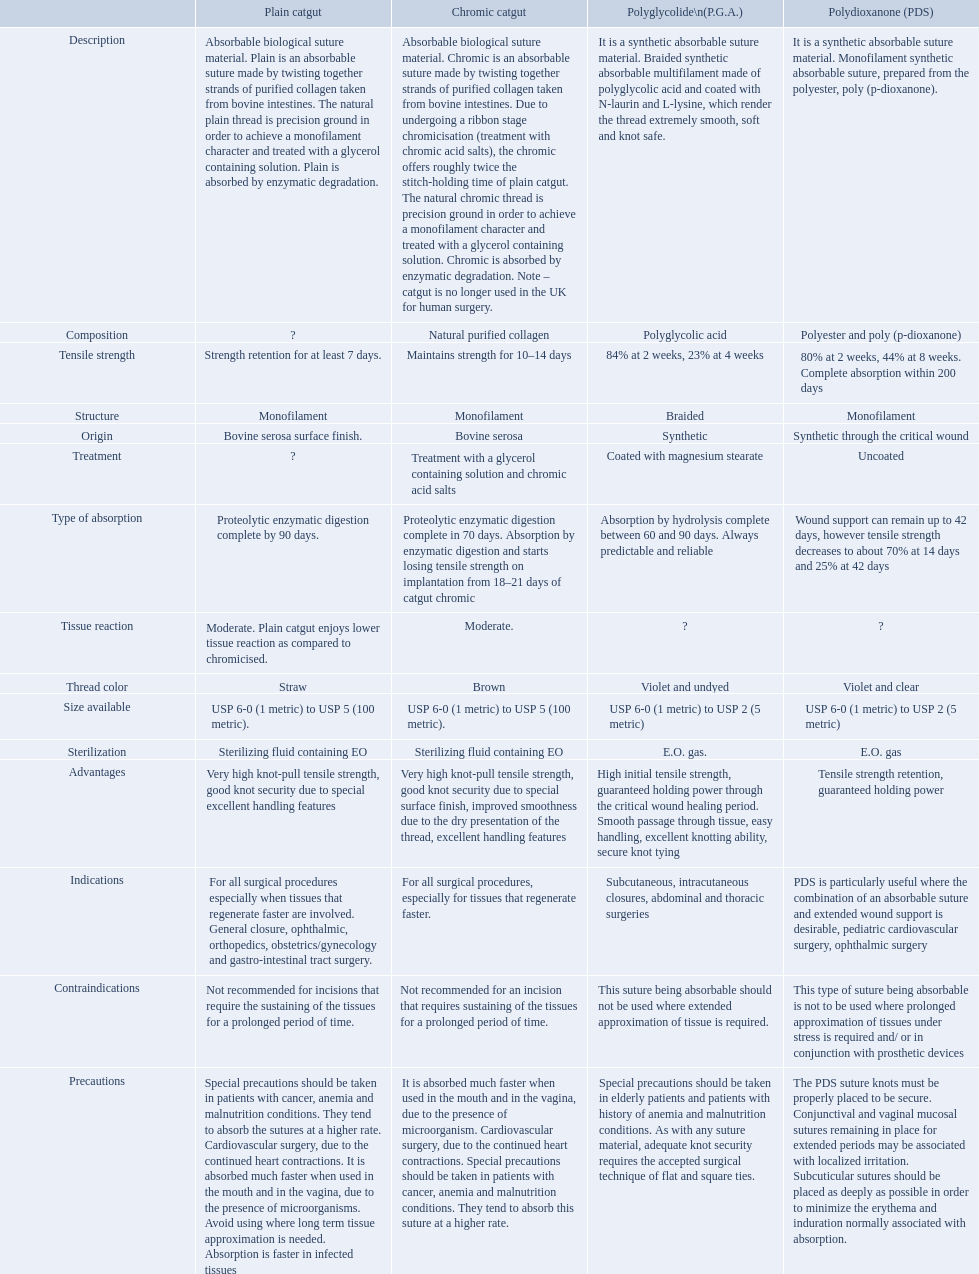How many days does the chronic catgut retain strength? Maintains strength for 10–14 days. What is plain catgut? Absorbable biological suture material. Plain is an absorbable suture made by twisting together strands of purified collagen taken from bovine intestines. The natural plain thread is precision ground in order to achieve a monofilament character and treated with a glycerol containing solution. Plain is absorbed by enzymatic degradation. How many days does catgut retain strength? Strength retention for at least 7 days. What categories are listed in the suture materials comparison chart? Description, Composition, Tensile strength, Structure, Origin, Treatment, Type of absorption, Tissue reaction, Thread color, Size available, Sterilization, Advantages, Indications, Contraindications, Precautions. Of the testile strength, which is the lowest? Strength retention for at least 7 days. Over how many days does chronic catgut keep its robustness? Maintains strength for 10–14 days. What is uncomplicated catgut? Absorbable biological suture material. Plain is an absorbable suture made by twisting together strands of purified collagen taken from bovine intestines. The natural plain thread is precision ground in order to achieve a monofilament character and treated with a glycerol containing solution. Plain is absorbed by enzymatic degradation. Can you give me this table as a dict? {'header': ['', 'Plain catgut', 'Chromic catgut', 'Polyglycolide\\n(P.G.A.)', 'Polydioxanone (PDS)'], 'rows': [['Description', 'Absorbable biological suture material. Plain is an absorbable suture made by twisting together strands of purified collagen taken from bovine intestines. The natural plain thread is precision ground in order to achieve a monofilament character and treated with a glycerol containing solution. Plain is absorbed by enzymatic degradation.', 'Absorbable biological suture material. Chromic is an absorbable suture made by twisting together strands of purified collagen taken from bovine intestines. Due to undergoing a ribbon stage chromicisation (treatment with chromic acid salts), the chromic offers roughly twice the stitch-holding time of plain catgut. The natural chromic thread is precision ground in order to achieve a monofilament character and treated with a glycerol containing solution. Chromic is absorbed by enzymatic degradation. Note – catgut is no longer used in the UK for human surgery.', 'It is a synthetic absorbable suture material. Braided synthetic absorbable multifilament made of polyglycolic acid and coated with N-laurin and L-lysine, which render the thread extremely smooth, soft and knot safe.', 'It is a synthetic absorbable suture material. Monofilament synthetic absorbable suture, prepared from the polyester, poly (p-dioxanone).'], ['Composition', '?', 'Natural purified collagen', 'Polyglycolic acid', 'Polyester and poly (p-dioxanone)'], ['Tensile strength', 'Strength retention for at least 7 days.', 'Maintains strength for 10–14 days', '84% at 2 weeks, 23% at 4 weeks', '80% at 2 weeks, 44% at 8 weeks. Complete absorption within 200 days'], ['Structure', 'Monofilament', 'Monofilament', 'Braided', 'Monofilament'], ['Origin', 'Bovine serosa surface finish.', 'Bovine serosa', 'Synthetic', 'Synthetic through the critical wound'], ['Treatment', '?', 'Treatment with a glycerol containing solution and chromic acid salts', 'Coated with magnesium stearate', 'Uncoated'], ['Type of absorption', 'Proteolytic enzymatic digestion complete by 90 days.', 'Proteolytic enzymatic digestion complete in 70 days. Absorption by enzymatic digestion and starts losing tensile strength on implantation from 18–21 days of catgut chromic', 'Absorption by hydrolysis complete between 60 and 90 days. Always predictable and reliable', 'Wound support can remain up to 42 days, however tensile strength decreases to about 70% at 14 days and 25% at 42 days'], ['Tissue reaction', 'Moderate. Plain catgut enjoys lower tissue reaction as compared to chromicised.', 'Moderate.', '?', '?'], ['Thread color', 'Straw', 'Brown', 'Violet and undyed', 'Violet and clear'], ['Size available', 'USP 6-0 (1 metric) to USP 5 (100 metric).', 'USP 6-0 (1 metric) to USP 5 (100 metric).', 'USP 6-0 (1 metric) to USP 2 (5 metric)', 'USP 6-0 (1 metric) to USP 2 (5 metric)'], ['Sterilization', 'Sterilizing fluid containing EO', 'Sterilizing fluid containing EO', 'E.O. gas.', 'E.O. gas'], ['Advantages', 'Very high knot-pull tensile strength, good knot security due to special excellent handling features', 'Very high knot-pull tensile strength, good knot security due to special surface finish, improved smoothness due to the dry presentation of the thread, excellent handling features', 'High initial tensile strength, guaranteed holding power through the critical wound healing period. Smooth passage through tissue, easy handling, excellent knotting ability, secure knot tying', 'Tensile strength retention, guaranteed holding power'], ['Indications', 'For all surgical procedures especially when tissues that regenerate faster are involved. General closure, ophthalmic, orthopedics, obstetrics/gynecology and gastro-intestinal tract surgery.', 'For all surgical procedures, especially for tissues that regenerate faster.', 'Subcutaneous, intracutaneous closures, abdominal and thoracic surgeries', 'PDS is particularly useful where the combination of an absorbable suture and extended wound support is desirable, pediatric cardiovascular surgery, ophthalmic surgery'], ['Contraindications', 'Not recommended for incisions that require the sustaining of the tissues for a prolonged period of time.', 'Not recommended for an incision that requires sustaining of the tissues for a prolonged period of time.', 'This suture being absorbable should not be used where extended approximation of tissue is required.', 'This type of suture being absorbable is not to be used where prolonged approximation of tissues under stress is required and/ or in conjunction with prosthetic devices'], ['Precautions', 'Special precautions should be taken in patients with cancer, anemia and malnutrition conditions. They tend to absorb the sutures at a higher rate. Cardiovascular surgery, due to the continued heart contractions. It is absorbed much faster when used in the mouth and in the vagina, due to the presence of microorganisms. Avoid using where long term tissue approximation is needed. Absorption is faster in infected tissues', 'It is absorbed much faster when used in the mouth and in the vagina, due to the presence of microorganism. Cardiovascular surgery, due to the continued heart contractions. Special precautions should be taken in patients with cancer, anemia and malnutrition conditions. They tend to absorb this suture at a higher rate.', 'Special precautions should be taken in elderly patients and patients with history of anemia and malnutrition conditions. As with any suture material, adequate knot security requires the accepted surgical technique of flat and square ties.', 'The PDS suture knots must be properly placed to be secure. Conjunctival and vaginal mucosal sutures remaining in place for extended periods may be associated with localized irritation. Subcuticular sutures should be placed as deeply as possible in order to minimize the erythema and induration normally associated with absorption.']]} Over how many days does catgut hold its robustness? Strength retention for at least 7 days. What is the duration of strength retention for chronic catgut? Maintains strength for 10–14 days. Can you define plain catgut? Absorbable biological suture material. Plain is an absorbable suture made by twisting together strands of purified collagen taken from bovine intestines. The natural plain thread is precision ground in order to achieve a monofilament character and treated with a glycerol containing solution. Plain is absorbed by enzymatic degradation. How long does catgut continue to hold its strength? Strength retention for at least 7 days. What are the various categories mentioned in the suture materials comparison chart? Description, Composition, Tensile strength, Structure, Origin, Treatment, Type of absorption, Tissue reaction, Thread color, Size available, Sterilization, Advantages, Indications, Contraindications, Precautions. Among textile strength, which one has the lowest value? Strength retention for at least 7 days. Can you parse all the data within this table? {'header': ['', 'Plain catgut', 'Chromic catgut', 'Polyglycolide\\n(P.G.A.)', 'Polydioxanone (PDS)'], 'rows': [['Description', 'Absorbable biological suture material. Plain is an absorbable suture made by twisting together strands of purified collagen taken from bovine intestines. The natural plain thread is precision ground in order to achieve a monofilament character and treated with a glycerol containing solution. Plain is absorbed by enzymatic degradation.', 'Absorbable biological suture material. Chromic is an absorbable suture made by twisting together strands of purified collagen taken from bovine intestines. Due to undergoing a ribbon stage chromicisation (treatment with chromic acid salts), the chromic offers roughly twice the stitch-holding time of plain catgut. The natural chromic thread is precision ground in order to achieve a monofilament character and treated with a glycerol containing solution. Chromic is absorbed by enzymatic degradation. Note – catgut is no longer used in the UK for human surgery.', 'It is a synthetic absorbable suture material. Braided synthetic absorbable multifilament made of polyglycolic acid and coated with N-laurin and L-lysine, which render the thread extremely smooth, soft and knot safe.', 'It is a synthetic absorbable suture material. Monofilament synthetic absorbable suture, prepared from the polyester, poly (p-dioxanone).'], ['Composition', '?', 'Natural purified collagen', 'Polyglycolic acid', 'Polyester and poly (p-dioxanone)'], ['Tensile strength', 'Strength retention for at least 7 days.', 'Maintains strength for 10–14 days', '84% at 2 weeks, 23% at 4 weeks', '80% at 2 weeks, 44% at 8 weeks. Complete absorption within 200 days'], ['Structure', 'Monofilament', 'Monofilament', 'Braided', 'Monofilament'], ['Origin', 'Bovine serosa surface finish.', 'Bovine serosa', 'Synthetic', 'Synthetic through the critical wound'], ['Treatment', '?', 'Treatment with a glycerol containing solution and chromic acid salts', 'Coated with magnesium stearate', 'Uncoated'], ['Type of absorption', 'Proteolytic enzymatic digestion complete by 90 days.', 'Proteolytic enzymatic digestion complete in 70 days. Absorption by enzymatic digestion and starts losing tensile strength on implantation from 18–21 days of catgut chromic', 'Absorption by hydrolysis complete between 60 and 90 days. Always predictable and reliable', 'Wound support can remain up to 42 days, however tensile strength decreases to about 70% at 14 days and 25% at 42 days'], ['Tissue reaction', 'Moderate. Plain catgut enjoys lower tissue reaction as compared to chromicised.', 'Moderate.', '?', '?'], ['Thread color', 'Straw', 'Brown', 'Violet and undyed', 'Violet and clear'], ['Size available', 'USP 6-0 (1 metric) to USP 5 (100 metric).', 'USP 6-0 (1 metric) to USP 5 (100 metric).', 'USP 6-0 (1 metric) to USP 2 (5 metric)', 'USP 6-0 (1 metric) to USP 2 (5 metric)'], ['Sterilization', 'Sterilizing fluid containing EO', 'Sterilizing fluid containing EO', 'E.O. gas.', 'E.O. gas'], ['Advantages', 'Very high knot-pull tensile strength, good knot security due to special excellent handling features', 'Very high knot-pull tensile strength, good knot security due to special surface finish, improved smoothness due to the dry presentation of the thread, excellent handling features', 'High initial tensile strength, guaranteed holding power through the critical wound healing period. Smooth passage through tissue, easy handling, excellent knotting ability, secure knot tying', 'Tensile strength retention, guaranteed holding power'], ['Indications', 'For all surgical procedures especially when tissues that regenerate faster are involved. General closure, ophthalmic, orthopedics, obstetrics/gynecology and gastro-intestinal tract surgery.', 'For all surgical procedures, especially for tissues that regenerate faster.', 'Subcutaneous, intracutaneous closures, abdominal and thoracic surgeries', 'PDS is particularly useful where the combination of an absorbable suture and extended wound support is desirable, pediatric cardiovascular surgery, ophthalmic surgery'], ['Contraindications', 'Not recommended for incisions that require the sustaining of the tissues for a prolonged period of time.', 'Not recommended for an incision that requires sustaining of the tissues for a prolonged period of time.', 'This suture being absorbable should not be used where extended approximation of tissue is required.', 'This type of suture being absorbable is not to be used where prolonged approximation of tissues under stress is required and/ or in conjunction with prosthetic devices'], ['Precautions', 'Special precautions should be taken in patients with cancer, anemia and malnutrition conditions. They tend to absorb the sutures at a higher rate. Cardiovascular surgery, due to the continued heart contractions. It is absorbed much faster when used in the mouth and in the vagina, due to the presence of microorganisms. Avoid using where long term tissue approximation is needed. Absorption is faster in infected tissues', 'It is absorbed much faster when used in the mouth and in the vagina, due to the presence of microorganism. Cardiovascular surgery, due to the continued heart contractions. Special precautions should be taken in patients with cancer, anemia and malnutrition conditions. They tend to absorb this suture at a higher rate.', 'Special precautions should be taken in elderly patients and patients with history of anemia and malnutrition conditions. As with any suture material, adequate knot security requires the accepted surgical technique of flat and square ties.', 'The PDS suture knots must be properly placed to be secure. Conjunctival and vaginal mucosal sutures remaining in place for extended periods may be associated with localized irritation. Subcuticular sutures should be placed as deeply as possible in order to minimize the erythema and induration normally associated with absorption.']]} Which categories can be observed in the comparison chart for suture materials? Description, Composition, Tensile strength, Structure, Origin, Treatment, Type of absorption, Tissue reaction, Thread color, Size available, Sterilization, Advantages, Indications, Contraindications, Precautions. Out of the textile strength, which one is the least? Strength retention for at least 7 days. 